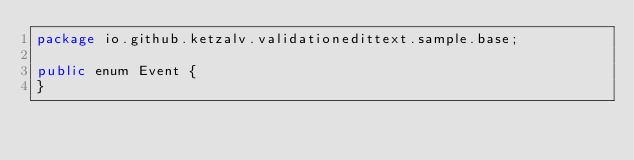<code> <loc_0><loc_0><loc_500><loc_500><_Java_>package io.github.ketzalv.validationedittext.sample.base;

public enum Event {
}

</code> 